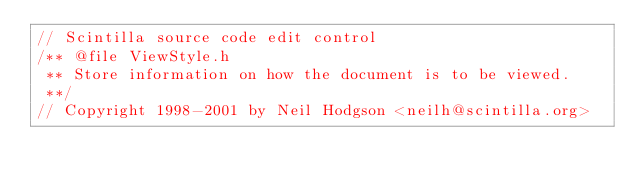Convert code to text. <code><loc_0><loc_0><loc_500><loc_500><_C_>// Scintilla source code edit control
/** @file ViewStyle.h
 ** Store information on how the document is to be viewed.
 **/
// Copyright 1998-2001 by Neil Hodgson <neilh@scintilla.org></code> 